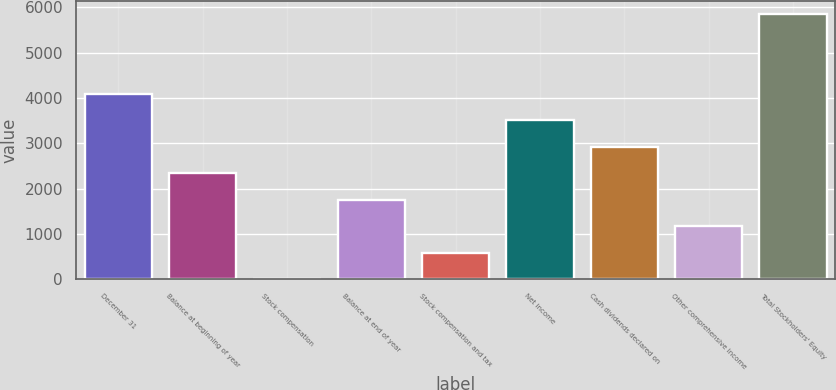Convert chart to OTSL. <chart><loc_0><loc_0><loc_500><loc_500><bar_chart><fcel>December 31<fcel>Balance at beginning of year<fcel>Stock compensation<fcel>Balance at end of year<fcel>Stock compensation and tax<fcel>Net income<fcel>Cash dividends declared on<fcel>Other comprehensive income<fcel>Total Stockholders' Equity<nl><fcel>4093.07<fcel>2339.24<fcel>0.8<fcel>1754.63<fcel>585.41<fcel>3508.46<fcel>2923.85<fcel>1170.02<fcel>5846.9<nl></chart> 